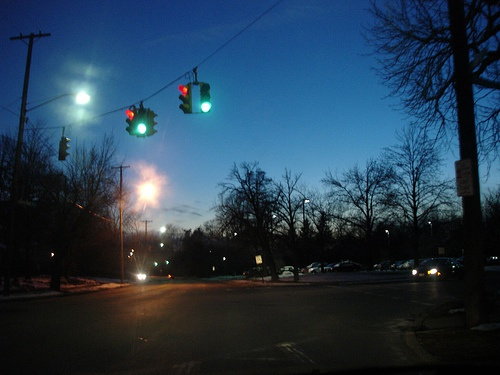Describe the objects in this image and their specific colors. I can see car in navy, black, white, gray, and maroon tones, traffic light in navy, black, and teal tones, traffic light in navy, teal, black, and darkgreen tones, car in navy, black, and teal tones, and car in navy, gray, white, and black tones in this image. 